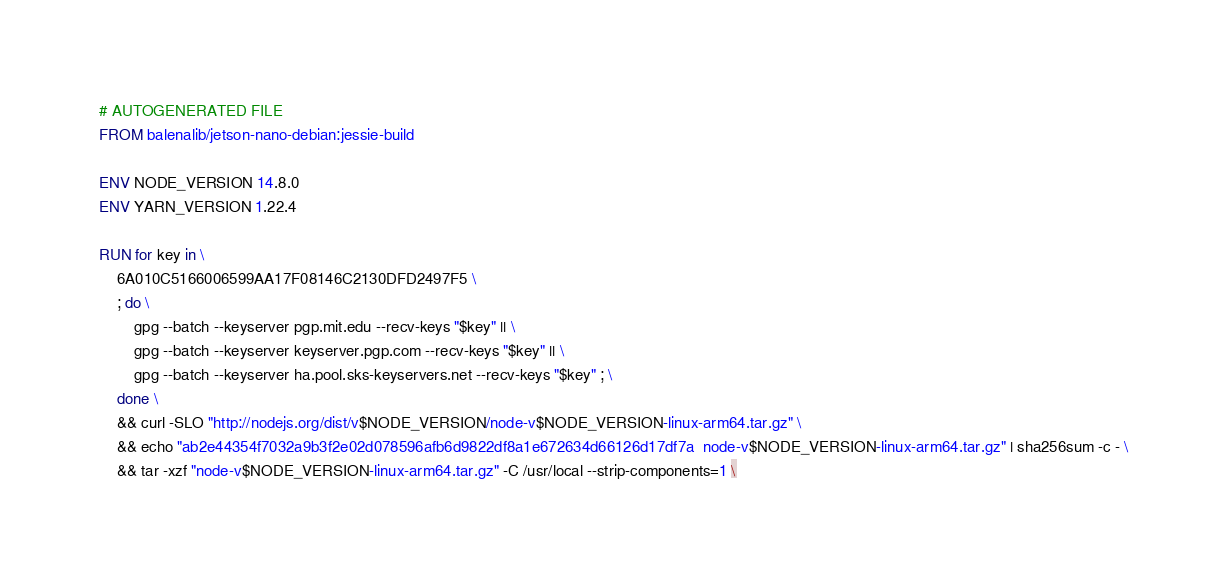<code> <loc_0><loc_0><loc_500><loc_500><_Dockerfile_># AUTOGENERATED FILE
FROM balenalib/jetson-nano-debian:jessie-build

ENV NODE_VERSION 14.8.0
ENV YARN_VERSION 1.22.4

RUN for key in \
	6A010C5166006599AA17F08146C2130DFD2497F5 \
	; do \
		gpg --batch --keyserver pgp.mit.edu --recv-keys "$key" || \
		gpg --batch --keyserver keyserver.pgp.com --recv-keys "$key" || \
		gpg --batch --keyserver ha.pool.sks-keyservers.net --recv-keys "$key" ; \
	done \
	&& curl -SLO "http://nodejs.org/dist/v$NODE_VERSION/node-v$NODE_VERSION-linux-arm64.tar.gz" \
	&& echo "ab2e44354f7032a9b3f2e02d078596afb6d9822df8a1e672634d66126d17df7a  node-v$NODE_VERSION-linux-arm64.tar.gz" | sha256sum -c - \
	&& tar -xzf "node-v$NODE_VERSION-linux-arm64.tar.gz" -C /usr/local --strip-components=1 \</code> 